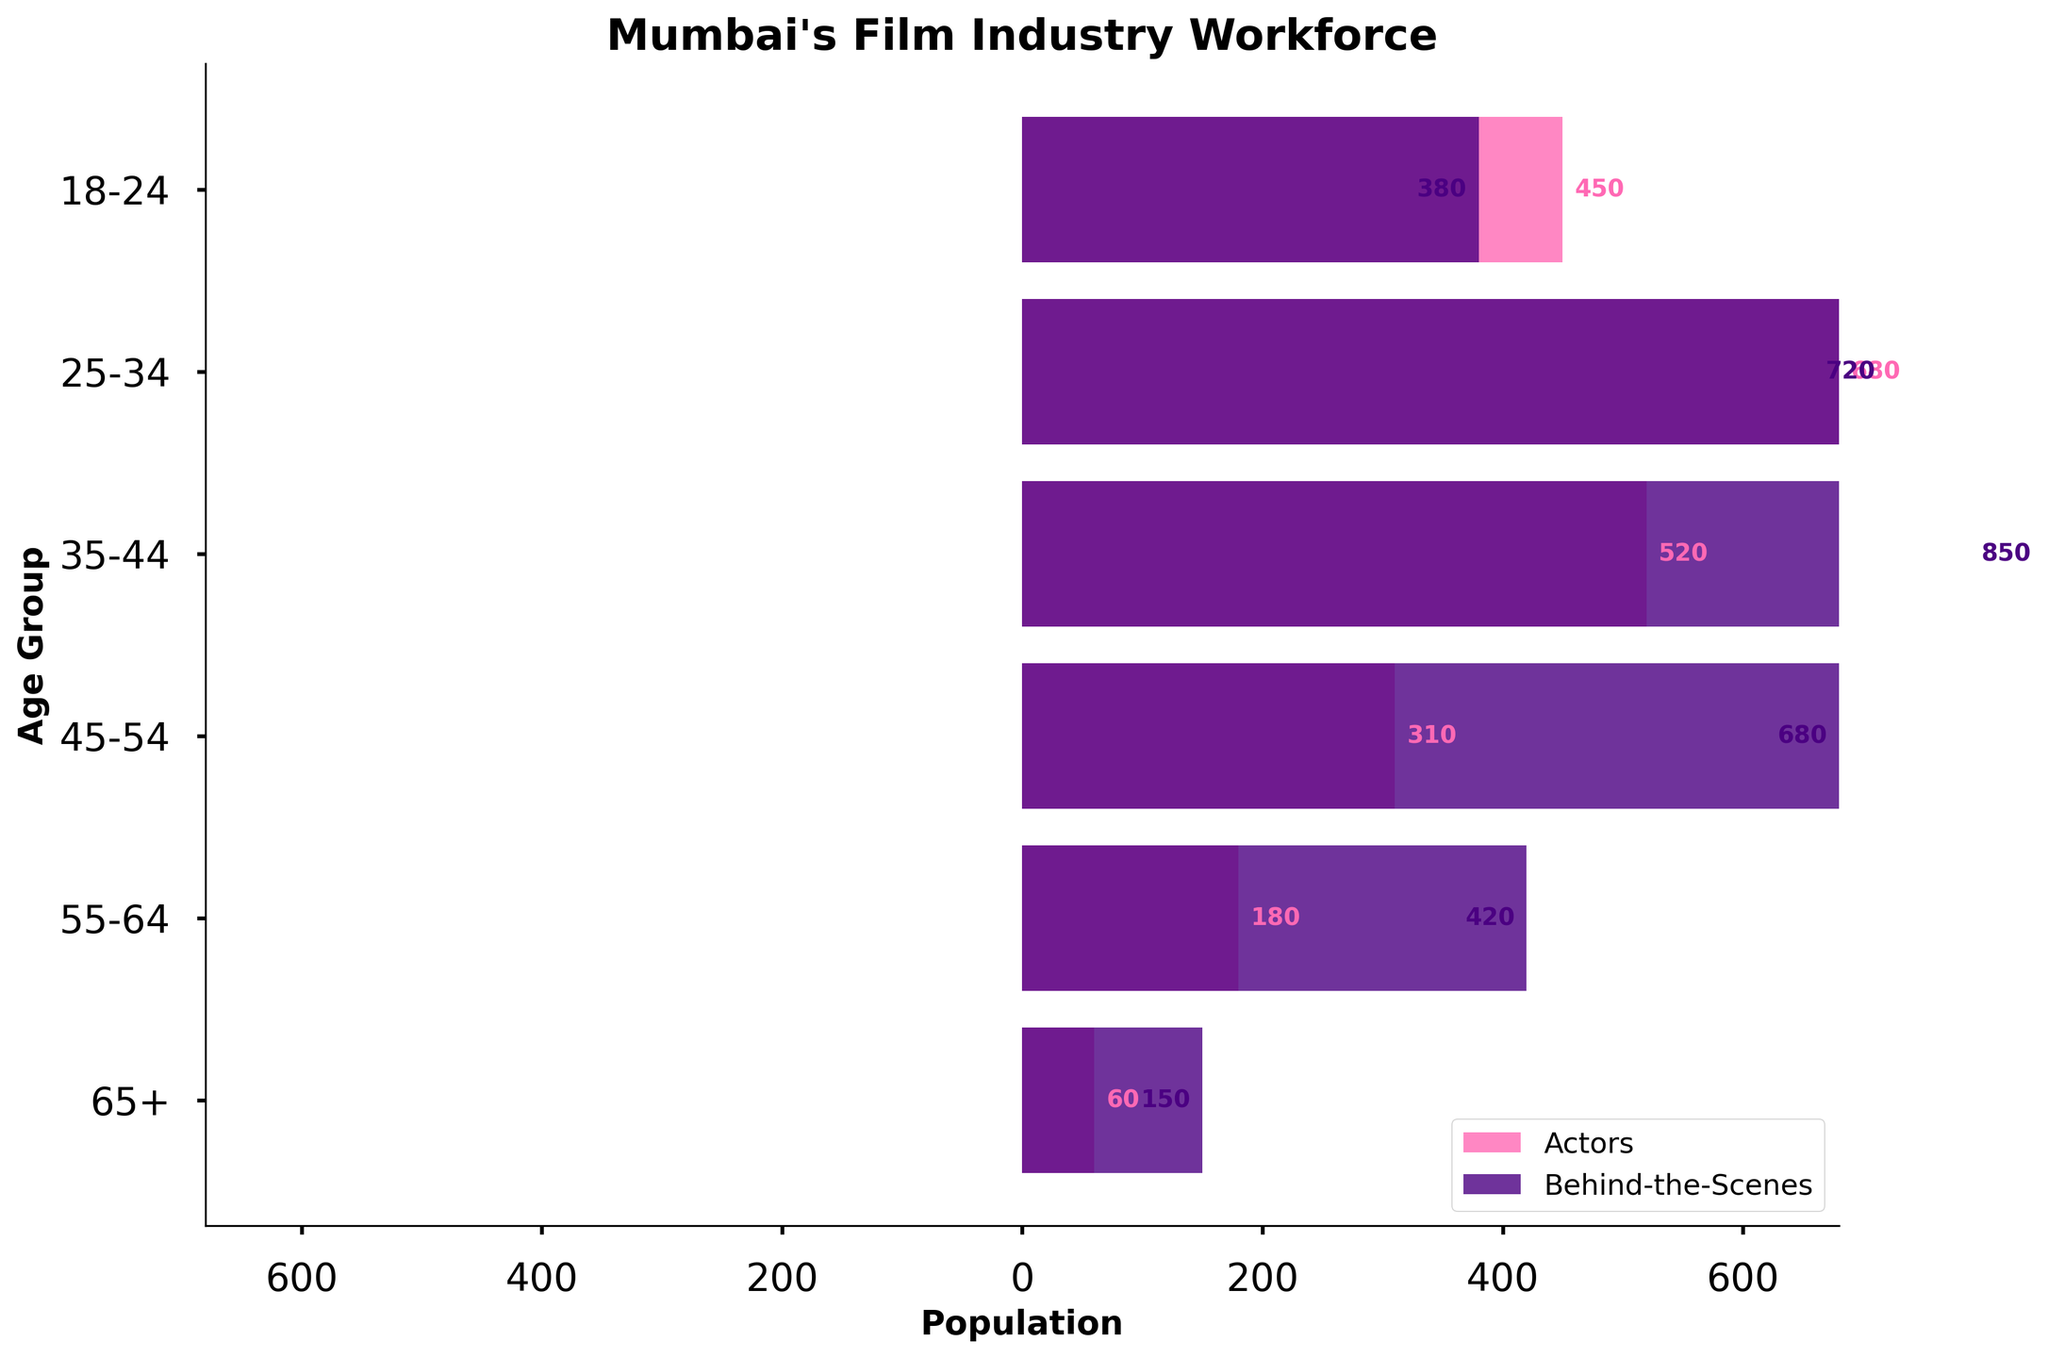What is the title of the figure? The title is displayed at the top of the figure. It reads "Mumbai's Film Industry Workforce".
Answer: Mumbai's Film Industry Workforce Which age group has the highest number of actors? The bar representing the 25-34 age group extends the farthest to the right.
Answer: 25-34 What colors are used for the actors and behind-the-scenes roles? The legend shows that actors are represented in pink and behind-the-scenes roles are in purple.
Answer: Pink (actors) and Purple (behind-the-scenes) How many age groups are there? The y-axis labels list six age groups.
Answer: 6 What is the total number of people working behind-the-scenes for the 35-44 age group? The behind-the-scenes bar for the 35-44 age group is the longest, representing 850 people.
Answer: 850 Which age group has the smallest number of people in behind-the-scenes roles? The behind-the-scenes bar for the 65+ age group is the shortest, with 150 people.
Answer: 65+ What is the difference in the number of actors between the 25-34 and 45-54 age groups? The number of actors in the 25-34 age group is 680, while it is 310 in the 45-54 age group. The difference is 680 - 310.
Answer: 370 What is the combined number of actors in the 35-44 and 45-54 age groups? The numbers of actors in the 35-44 and 45-54 age groups are 520 and 310, respectively. The combined number is 520 + 310.
Answer: 830 Which age group shows a greater disparity between actors and behind-the-scenes roles? The age group with the largest difference between the two bars is the 35-44 age group, with 520 actors and 850 behind-the-scenes, a disparity of 330.
Answer: 35-44 What is the second-largest age group for behind-the-scenes roles? After the 35-44 group with 850 people, the 25-34 group has the second-largest number of behind-the-scenes individuals, with 720 people.
Answer: 25-34 